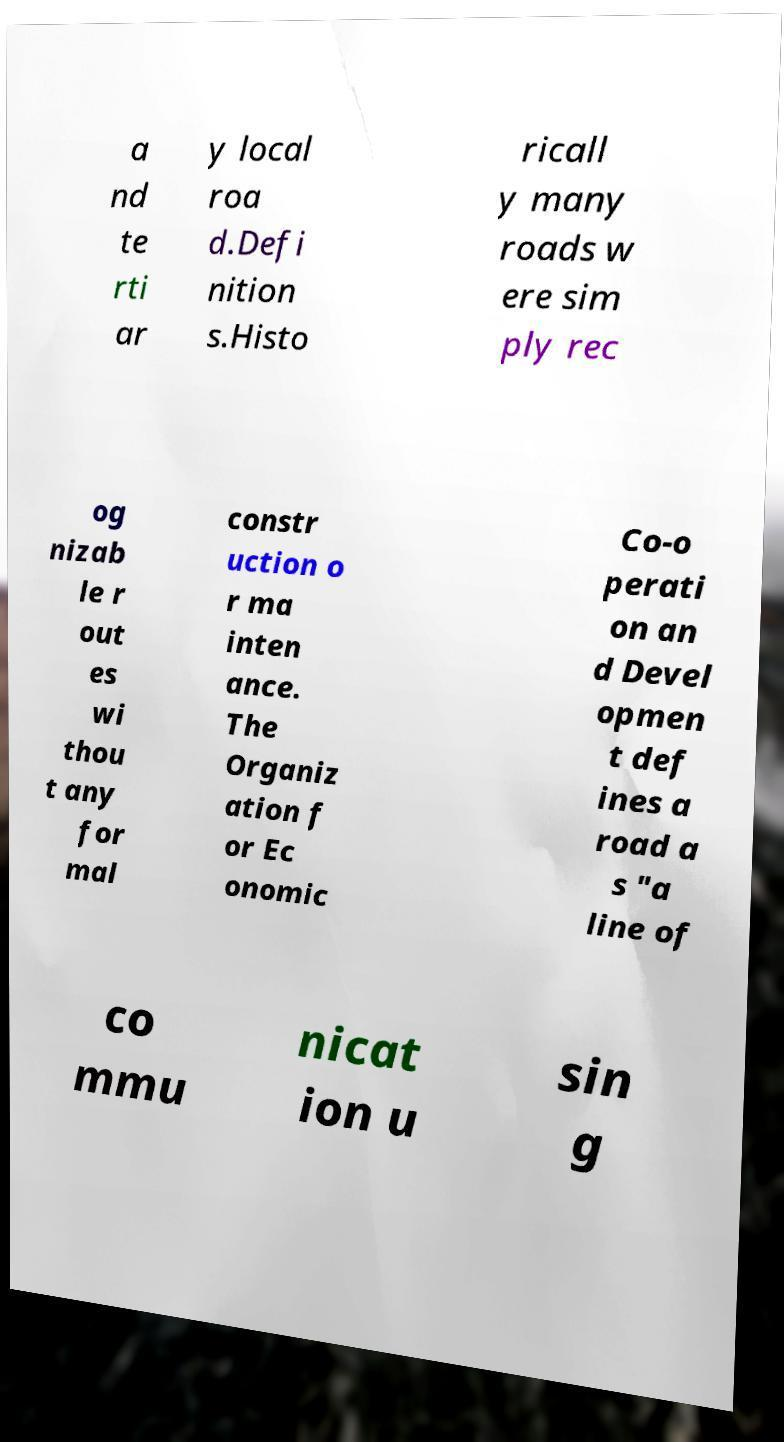Could you extract and type out the text from this image? a nd te rti ar y local roa d.Defi nition s.Histo ricall y many roads w ere sim ply rec og nizab le r out es wi thou t any for mal constr uction o r ma inten ance. The Organiz ation f or Ec onomic Co-o perati on an d Devel opmen t def ines a road a s "a line of co mmu nicat ion u sin g 